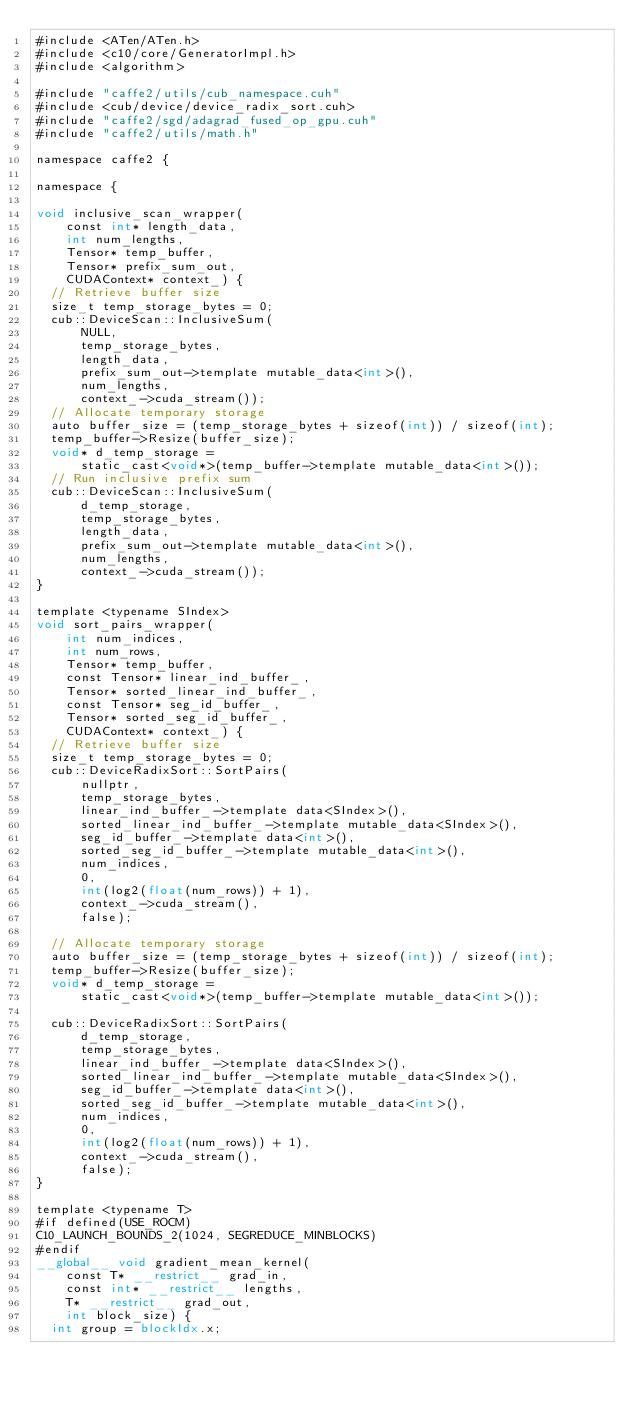<code> <loc_0><loc_0><loc_500><loc_500><_Cuda_>#include <ATen/ATen.h>
#include <c10/core/GeneratorImpl.h>
#include <algorithm>

#include "caffe2/utils/cub_namespace.cuh"
#include <cub/device/device_radix_sort.cuh>
#include "caffe2/sgd/adagrad_fused_op_gpu.cuh"
#include "caffe2/utils/math.h"

namespace caffe2 {

namespace {

void inclusive_scan_wrapper(
    const int* length_data,
    int num_lengths,
    Tensor* temp_buffer,
    Tensor* prefix_sum_out,
    CUDAContext* context_) {
  // Retrieve buffer size
  size_t temp_storage_bytes = 0;
  cub::DeviceScan::InclusiveSum(
      NULL,
      temp_storage_bytes,
      length_data,
      prefix_sum_out->template mutable_data<int>(),
      num_lengths,
      context_->cuda_stream());
  // Allocate temporary storage
  auto buffer_size = (temp_storage_bytes + sizeof(int)) / sizeof(int);
  temp_buffer->Resize(buffer_size);
  void* d_temp_storage =
      static_cast<void*>(temp_buffer->template mutable_data<int>());
  // Run inclusive prefix sum
  cub::DeviceScan::InclusiveSum(
      d_temp_storage,
      temp_storage_bytes,
      length_data,
      prefix_sum_out->template mutable_data<int>(),
      num_lengths,
      context_->cuda_stream());
}

template <typename SIndex>
void sort_pairs_wrapper(
    int num_indices,
    int num_rows,
    Tensor* temp_buffer,
    const Tensor* linear_ind_buffer_,
    Tensor* sorted_linear_ind_buffer_,
    const Tensor* seg_id_buffer_,
    Tensor* sorted_seg_id_buffer_,
    CUDAContext* context_) {
  // Retrieve buffer size
  size_t temp_storage_bytes = 0;
  cub::DeviceRadixSort::SortPairs(
      nullptr,
      temp_storage_bytes,
      linear_ind_buffer_->template data<SIndex>(),
      sorted_linear_ind_buffer_->template mutable_data<SIndex>(),
      seg_id_buffer_->template data<int>(),
      sorted_seg_id_buffer_->template mutable_data<int>(),
      num_indices,
      0,
      int(log2(float(num_rows)) + 1),
      context_->cuda_stream(),
      false);

  // Allocate temporary storage
  auto buffer_size = (temp_storage_bytes + sizeof(int)) / sizeof(int);
  temp_buffer->Resize(buffer_size);
  void* d_temp_storage =
      static_cast<void*>(temp_buffer->template mutable_data<int>());

  cub::DeviceRadixSort::SortPairs(
      d_temp_storage,
      temp_storage_bytes,
      linear_ind_buffer_->template data<SIndex>(),
      sorted_linear_ind_buffer_->template mutable_data<SIndex>(),
      seg_id_buffer_->template data<int>(),
      sorted_seg_id_buffer_->template mutable_data<int>(),
      num_indices,
      0,
      int(log2(float(num_rows)) + 1),
      context_->cuda_stream(),
      false);
}

template <typename T>
#if defined(USE_ROCM)
C10_LAUNCH_BOUNDS_2(1024, SEGREDUCE_MINBLOCKS)
#endif
__global__ void gradient_mean_kernel(
    const T* __restrict__ grad_in,
    const int* __restrict__ lengths,
    T* __restrict__ grad_out,
    int block_size) {
  int group = blockIdx.x;
</code> 